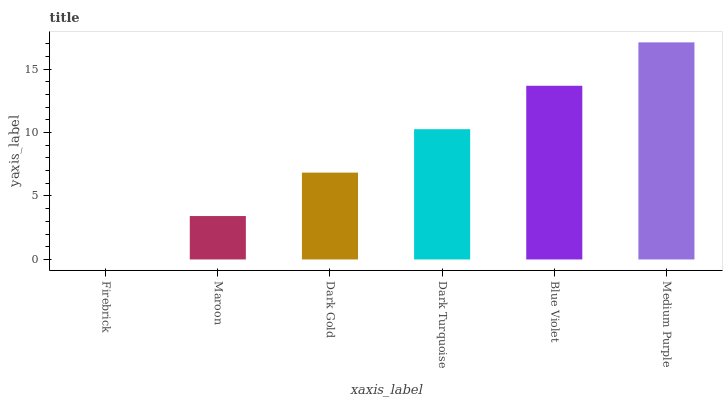Is Maroon the minimum?
Answer yes or no. No. Is Maroon the maximum?
Answer yes or no. No. Is Maroon greater than Firebrick?
Answer yes or no. Yes. Is Firebrick less than Maroon?
Answer yes or no. Yes. Is Firebrick greater than Maroon?
Answer yes or no. No. Is Maroon less than Firebrick?
Answer yes or no. No. Is Dark Turquoise the high median?
Answer yes or no. Yes. Is Dark Gold the low median?
Answer yes or no. Yes. Is Blue Violet the high median?
Answer yes or no. No. Is Medium Purple the low median?
Answer yes or no. No. 